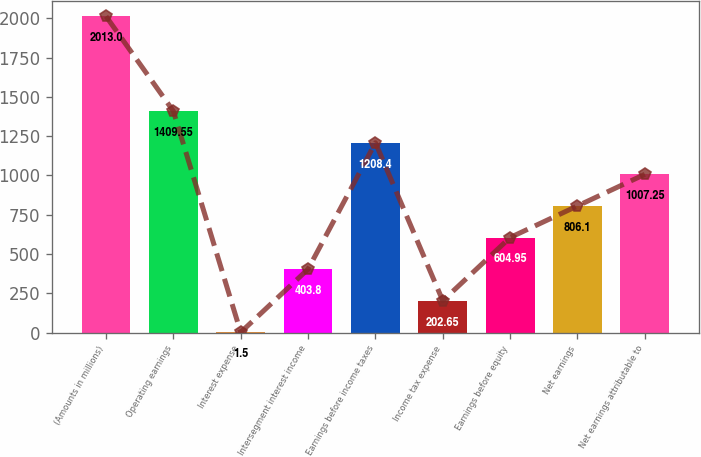Convert chart to OTSL. <chart><loc_0><loc_0><loc_500><loc_500><bar_chart><fcel>(Amounts in millions)<fcel>Operating earnings<fcel>Interest expense<fcel>Intersegment interest income<fcel>Earnings before income taxes<fcel>Income tax expense<fcel>Earnings before equity<fcel>Net earnings<fcel>Net earnings attributable to<nl><fcel>2013<fcel>1409.55<fcel>1.5<fcel>403.8<fcel>1208.4<fcel>202.65<fcel>604.95<fcel>806.1<fcel>1007.25<nl></chart> 